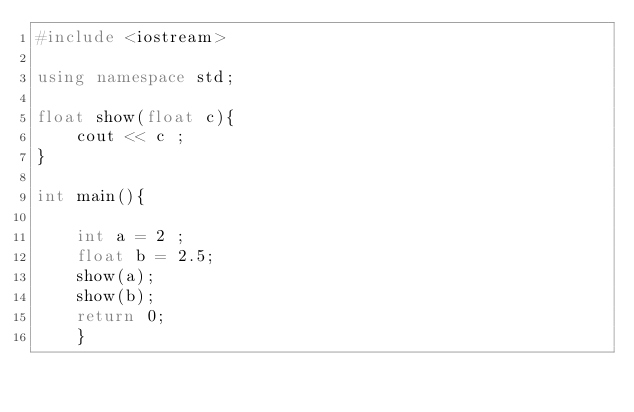<code> <loc_0><loc_0><loc_500><loc_500><_C++_>#include <iostream>

using namespace std;

float show(float c){
    cout << c ;
}

int main(){

    int a = 2 ;
    float b = 2.5;
    show(a);
    show(b);
    return 0;
    }
</code> 